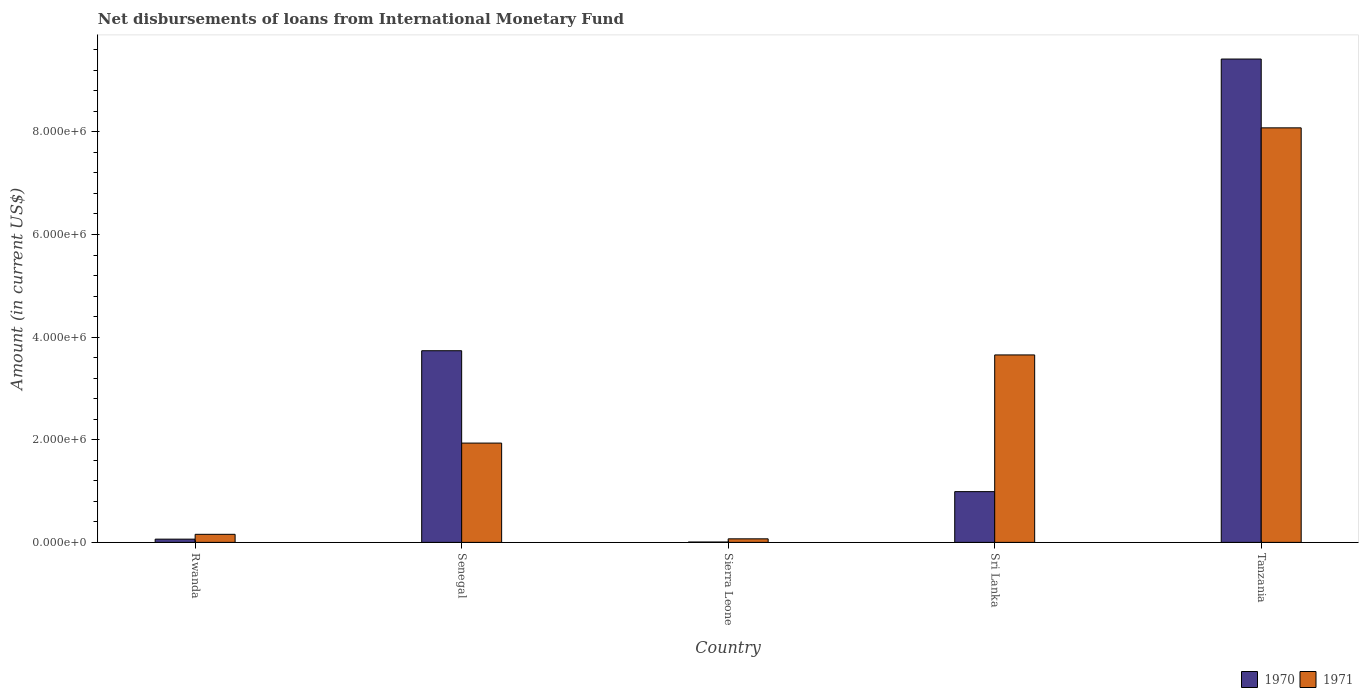How many different coloured bars are there?
Ensure brevity in your answer.  2. How many bars are there on the 5th tick from the right?
Keep it short and to the point. 2. What is the label of the 2nd group of bars from the left?
Provide a short and direct response. Senegal. What is the amount of loans disbursed in 1970 in Senegal?
Make the answer very short. 3.74e+06. Across all countries, what is the maximum amount of loans disbursed in 1971?
Your response must be concise. 8.08e+06. Across all countries, what is the minimum amount of loans disbursed in 1971?
Keep it short and to the point. 6.90e+04. In which country was the amount of loans disbursed in 1970 maximum?
Your answer should be very brief. Tanzania. In which country was the amount of loans disbursed in 1970 minimum?
Provide a short and direct response. Sierra Leone. What is the total amount of loans disbursed in 1971 in the graph?
Make the answer very short. 1.39e+07. What is the difference between the amount of loans disbursed in 1970 in Rwanda and that in Senegal?
Make the answer very short. -3.67e+06. What is the difference between the amount of loans disbursed in 1970 in Senegal and the amount of loans disbursed in 1971 in Rwanda?
Your response must be concise. 3.58e+06. What is the average amount of loans disbursed in 1970 per country?
Keep it short and to the point. 2.84e+06. What is the difference between the amount of loans disbursed of/in 1971 and amount of loans disbursed of/in 1970 in Tanzania?
Ensure brevity in your answer.  -1.34e+06. What is the ratio of the amount of loans disbursed in 1971 in Sierra Leone to that in Sri Lanka?
Offer a terse response. 0.02. Is the amount of loans disbursed in 1970 in Rwanda less than that in Senegal?
Ensure brevity in your answer.  Yes. What is the difference between the highest and the second highest amount of loans disbursed in 1970?
Keep it short and to the point. 8.43e+06. What is the difference between the highest and the lowest amount of loans disbursed in 1971?
Offer a very short reply. 8.01e+06. In how many countries, is the amount of loans disbursed in 1970 greater than the average amount of loans disbursed in 1970 taken over all countries?
Offer a terse response. 2. Is the sum of the amount of loans disbursed in 1971 in Senegal and Sierra Leone greater than the maximum amount of loans disbursed in 1970 across all countries?
Give a very brief answer. No. What does the 1st bar from the right in Senegal represents?
Ensure brevity in your answer.  1971. How many countries are there in the graph?
Your answer should be compact. 5. What is the difference between two consecutive major ticks on the Y-axis?
Provide a short and direct response. 2.00e+06. Are the values on the major ticks of Y-axis written in scientific E-notation?
Your answer should be very brief. Yes. Does the graph contain any zero values?
Your answer should be compact. No. Where does the legend appear in the graph?
Offer a very short reply. Bottom right. How are the legend labels stacked?
Provide a succinct answer. Horizontal. What is the title of the graph?
Offer a terse response. Net disbursements of loans from International Monetary Fund. Does "1967" appear as one of the legend labels in the graph?
Provide a short and direct response. No. What is the label or title of the X-axis?
Keep it short and to the point. Country. What is the Amount (in current US$) of 1970 in Rwanda?
Keep it short and to the point. 6.30e+04. What is the Amount (in current US$) in 1971 in Rwanda?
Provide a short and direct response. 1.57e+05. What is the Amount (in current US$) in 1970 in Senegal?
Your answer should be very brief. 3.74e+06. What is the Amount (in current US$) of 1971 in Senegal?
Provide a succinct answer. 1.94e+06. What is the Amount (in current US$) of 1970 in Sierra Leone?
Offer a terse response. 7000. What is the Amount (in current US$) in 1971 in Sierra Leone?
Keep it short and to the point. 6.90e+04. What is the Amount (in current US$) of 1970 in Sri Lanka?
Your answer should be very brief. 9.89e+05. What is the Amount (in current US$) in 1971 in Sri Lanka?
Your answer should be compact. 3.65e+06. What is the Amount (in current US$) in 1970 in Tanzania?
Make the answer very short. 9.42e+06. What is the Amount (in current US$) of 1971 in Tanzania?
Keep it short and to the point. 8.08e+06. Across all countries, what is the maximum Amount (in current US$) in 1970?
Provide a short and direct response. 9.42e+06. Across all countries, what is the maximum Amount (in current US$) of 1971?
Offer a very short reply. 8.08e+06. Across all countries, what is the minimum Amount (in current US$) of 1970?
Your answer should be compact. 7000. Across all countries, what is the minimum Amount (in current US$) in 1971?
Give a very brief answer. 6.90e+04. What is the total Amount (in current US$) of 1970 in the graph?
Ensure brevity in your answer.  1.42e+07. What is the total Amount (in current US$) in 1971 in the graph?
Provide a succinct answer. 1.39e+07. What is the difference between the Amount (in current US$) of 1970 in Rwanda and that in Senegal?
Your response must be concise. -3.67e+06. What is the difference between the Amount (in current US$) in 1971 in Rwanda and that in Senegal?
Your response must be concise. -1.78e+06. What is the difference between the Amount (in current US$) in 1970 in Rwanda and that in Sierra Leone?
Your response must be concise. 5.60e+04. What is the difference between the Amount (in current US$) of 1971 in Rwanda and that in Sierra Leone?
Your answer should be very brief. 8.80e+04. What is the difference between the Amount (in current US$) of 1970 in Rwanda and that in Sri Lanka?
Your answer should be compact. -9.26e+05. What is the difference between the Amount (in current US$) of 1971 in Rwanda and that in Sri Lanka?
Make the answer very short. -3.50e+06. What is the difference between the Amount (in current US$) in 1970 in Rwanda and that in Tanzania?
Ensure brevity in your answer.  -9.36e+06. What is the difference between the Amount (in current US$) in 1971 in Rwanda and that in Tanzania?
Provide a succinct answer. -7.92e+06. What is the difference between the Amount (in current US$) of 1970 in Senegal and that in Sierra Leone?
Ensure brevity in your answer.  3.73e+06. What is the difference between the Amount (in current US$) of 1971 in Senegal and that in Sierra Leone?
Ensure brevity in your answer.  1.87e+06. What is the difference between the Amount (in current US$) in 1970 in Senegal and that in Sri Lanka?
Give a very brief answer. 2.75e+06. What is the difference between the Amount (in current US$) in 1971 in Senegal and that in Sri Lanka?
Offer a terse response. -1.72e+06. What is the difference between the Amount (in current US$) of 1970 in Senegal and that in Tanzania?
Offer a very short reply. -5.68e+06. What is the difference between the Amount (in current US$) of 1971 in Senegal and that in Tanzania?
Your answer should be compact. -6.14e+06. What is the difference between the Amount (in current US$) of 1970 in Sierra Leone and that in Sri Lanka?
Offer a very short reply. -9.82e+05. What is the difference between the Amount (in current US$) in 1971 in Sierra Leone and that in Sri Lanka?
Provide a succinct answer. -3.58e+06. What is the difference between the Amount (in current US$) in 1970 in Sierra Leone and that in Tanzania?
Your answer should be compact. -9.41e+06. What is the difference between the Amount (in current US$) of 1971 in Sierra Leone and that in Tanzania?
Your answer should be compact. -8.01e+06. What is the difference between the Amount (in current US$) in 1970 in Sri Lanka and that in Tanzania?
Offer a terse response. -8.43e+06. What is the difference between the Amount (in current US$) in 1971 in Sri Lanka and that in Tanzania?
Give a very brief answer. -4.42e+06. What is the difference between the Amount (in current US$) of 1970 in Rwanda and the Amount (in current US$) of 1971 in Senegal?
Keep it short and to the point. -1.87e+06. What is the difference between the Amount (in current US$) of 1970 in Rwanda and the Amount (in current US$) of 1971 in Sierra Leone?
Offer a very short reply. -6000. What is the difference between the Amount (in current US$) in 1970 in Rwanda and the Amount (in current US$) in 1971 in Sri Lanka?
Offer a very short reply. -3.59e+06. What is the difference between the Amount (in current US$) of 1970 in Rwanda and the Amount (in current US$) of 1971 in Tanzania?
Your response must be concise. -8.02e+06. What is the difference between the Amount (in current US$) in 1970 in Senegal and the Amount (in current US$) in 1971 in Sierra Leone?
Your response must be concise. 3.67e+06. What is the difference between the Amount (in current US$) in 1970 in Senegal and the Amount (in current US$) in 1971 in Sri Lanka?
Provide a short and direct response. 8.20e+04. What is the difference between the Amount (in current US$) of 1970 in Senegal and the Amount (in current US$) of 1971 in Tanzania?
Your answer should be compact. -4.34e+06. What is the difference between the Amount (in current US$) in 1970 in Sierra Leone and the Amount (in current US$) in 1971 in Sri Lanka?
Your answer should be very brief. -3.65e+06. What is the difference between the Amount (in current US$) of 1970 in Sierra Leone and the Amount (in current US$) of 1971 in Tanzania?
Offer a terse response. -8.07e+06. What is the difference between the Amount (in current US$) in 1970 in Sri Lanka and the Amount (in current US$) in 1971 in Tanzania?
Your response must be concise. -7.09e+06. What is the average Amount (in current US$) of 1970 per country?
Ensure brevity in your answer.  2.84e+06. What is the average Amount (in current US$) in 1971 per country?
Ensure brevity in your answer.  2.78e+06. What is the difference between the Amount (in current US$) in 1970 and Amount (in current US$) in 1971 in Rwanda?
Your answer should be very brief. -9.40e+04. What is the difference between the Amount (in current US$) in 1970 and Amount (in current US$) in 1971 in Senegal?
Your answer should be compact. 1.80e+06. What is the difference between the Amount (in current US$) in 1970 and Amount (in current US$) in 1971 in Sierra Leone?
Offer a terse response. -6.20e+04. What is the difference between the Amount (in current US$) of 1970 and Amount (in current US$) of 1971 in Sri Lanka?
Your answer should be compact. -2.66e+06. What is the difference between the Amount (in current US$) of 1970 and Amount (in current US$) of 1971 in Tanzania?
Offer a very short reply. 1.34e+06. What is the ratio of the Amount (in current US$) in 1970 in Rwanda to that in Senegal?
Offer a terse response. 0.02. What is the ratio of the Amount (in current US$) of 1971 in Rwanda to that in Senegal?
Your answer should be very brief. 0.08. What is the ratio of the Amount (in current US$) in 1970 in Rwanda to that in Sierra Leone?
Your answer should be compact. 9. What is the ratio of the Amount (in current US$) of 1971 in Rwanda to that in Sierra Leone?
Provide a short and direct response. 2.28. What is the ratio of the Amount (in current US$) in 1970 in Rwanda to that in Sri Lanka?
Give a very brief answer. 0.06. What is the ratio of the Amount (in current US$) of 1971 in Rwanda to that in Sri Lanka?
Your answer should be compact. 0.04. What is the ratio of the Amount (in current US$) in 1970 in Rwanda to that in Tanzania?
Keep it short and to the point. 0.01. What is the ratio of the Amount (in current US$) in 1971 in Rwanda to that in Tanzania?
Keep it short and to the point. 0.02. What is the ratio of the Amount (in current US$) of 1970 in Senegal to that in Sierra Leone?
Make the answer very short. 533.57. What is the ratio of the Amount (in current US$) in 1971 in Senegal to that in Sierra Leone?
Make the answer very short. 28.04. What is the ratio of the Amount (in current US$) in 1970 in Senegal to that in Sri Lanka?
Keep it short and to the point. 3.78. What is the ratio of the Amount (in current US$) in 1971 in Senegal to that in Sri Lanka?
Your answer should be compact. 0.53. What is the ratio of the Amount (in current US$) of 1970 in Senegal to that in Tanzania?
Provide a short and direct response. 0.4. What is the ratio of the Amount (in current US$) of 1971 in Senegal to that in Tanzania?
Ensure brevity in your answer.  0.24. What is the ratio of the Amount (in current US$) in 1970 in Sierra Leone to that in Sri Lanka?
Your response must be concise. 0.01. What is the ratio of the Amount (in current US$) of 1971 in Sierra Leone to that in Sri Lanka?
Keep it short and to the point. 0.02. What is the ratio of the Amount (in current US$) of 1970 in Sierra Leone to that in Tanzania?
Make the answer very short. 0. What is the ratio of the Amount (in current US$) of 1971 in Sierra Leone to that in Tanzania?
Keep it short and to the point. 0.01. What is the ratio of the Amount (in current US$) in 1970 in Sri Lanka to that in Tanzania?
Provide a succinct answer. 0.1. What is the ratio of the Amount (in current US$) in 1971 in Sri Lanka to that in Tanzania?
Offer a very short reply. 0.45. What is the difference between the highest and the second highest Amount (in current US$) of 1970?
Offer a terse response. 5.68e+06. What is the difference between the highest and the second highest Amount (in current US$) of 1971?
Make the answer very short. 4.42e+06. What is the difference between the highest and the lowest Amount (in current US$) of 1970?
Give a very brief answer. 9.41e+06. What is the difference between the highest and the lowest Amount (in current US$) in 1971?
Offer a very short reply. 8.01e+06. 